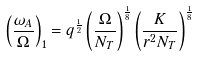<formula> <loc_0><loc_0><loc_500><loc_500>\left ( \frac { \omega _ { A } } { \Omega } \right ) _ { 1 } = q ^ { \frac { 1 } { 2 } } \left ( \frac { \Omega } { N _ { T } } \right ) ^ { \frac { 1 } { 8 } } \left ( \frac { K } { r ^ { 2 } N _ { T } } \right ) ^ { \frac { 1 } { 8 } } \,</formula> 